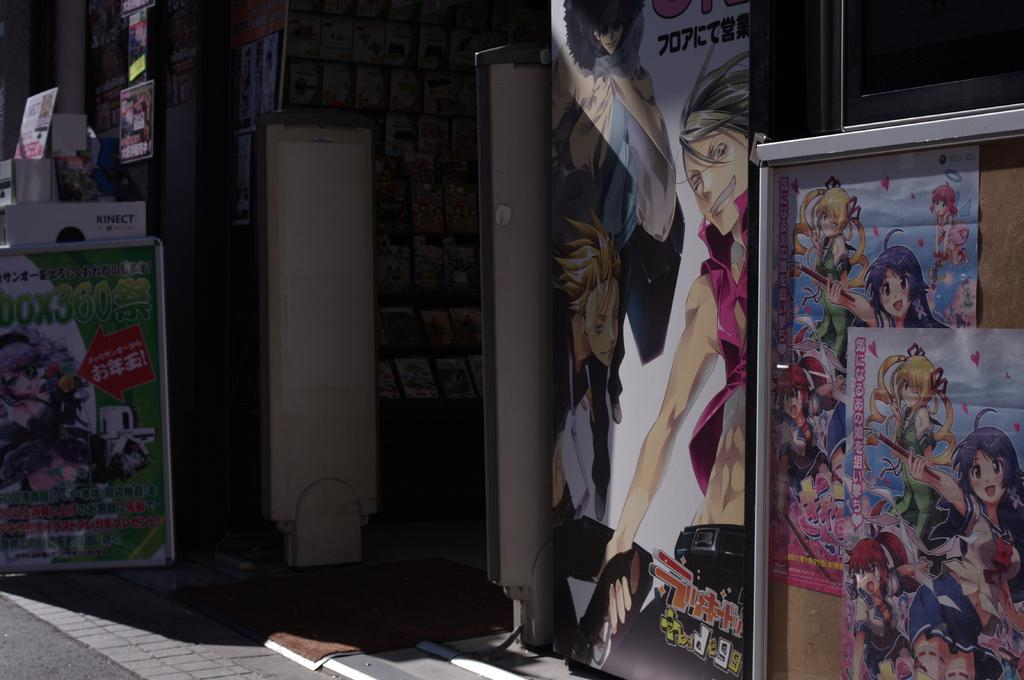What is the main feature of the image? The main feature of the image is the many boards. What is located in front of the store? There is a mat in-front of the store. How are some of the boards related to the store? Some boards are attached to the store. What can be seen inside the store? There are objects visible inside the store. What is a noticeable characteristic of the boards? The boards are colorful. What type of jam is being sold inside the store? There is no indication of jam being sold inside the store in the image. What variety of yam is being advertised on the boards? There is no mention of yams or any agricultural products on the boards in the image. 